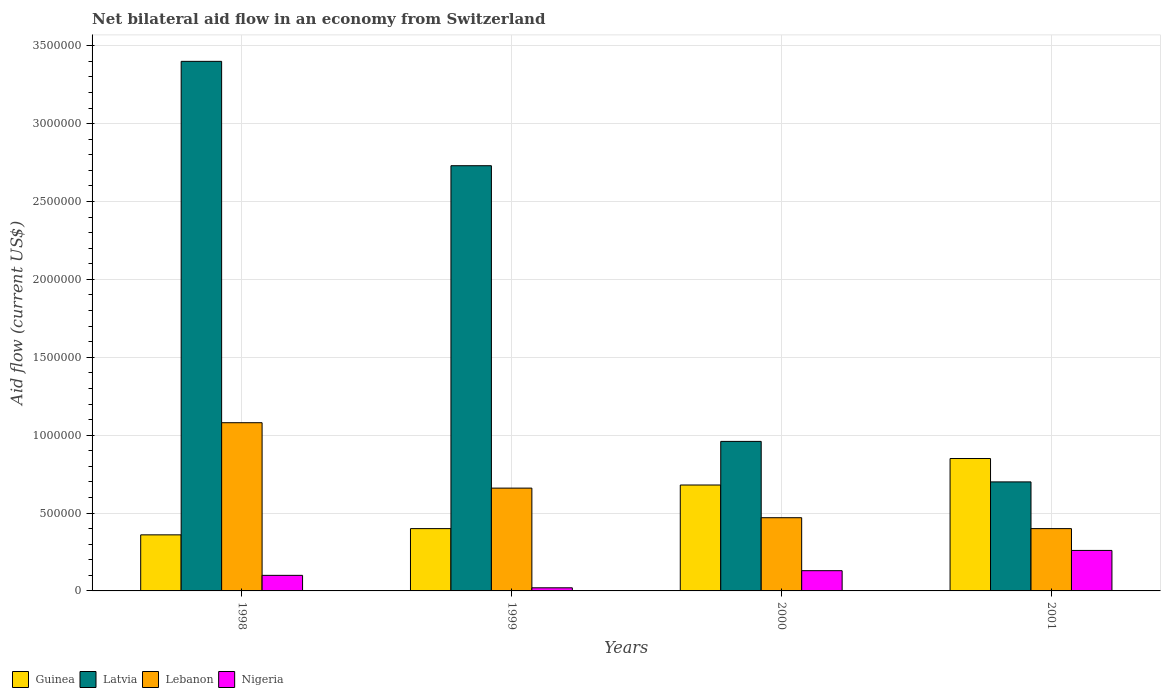How many different coloured bars are there?
Your answer should be compact. 4. How many groups of bars are there?
Make the answer very short. 4. What is the net bilateral aid flow in Latvia in 1998?
Offer a very short reply. 3.40e+06. Across all years, what is the maximum net bilateral aid flow in Lebanon?
Your answer should be compact. 1.08e+06. Across all years, what is the minimum net bilateral aid flow in Lebanon?
Offer a terse response. 4.00e+05. In which year was the net bilateral aid flow in Nigeria maximum?
Your response must be concise. 2001. In which year was the net bilateral aid flow in Nigeria minimum?
Keep it short and to the point. 1999. What is the total net bilateral aid flow in Nigeria in the graph?
Make the answer very short. 5.10e+05. What is the difference between the net bilateral aid flow in Lebanon in 1999 and that in 2001?
Your answer should be compact. 2.60e+05. What is the difference between the net bilateral aid flow in Lebanon in 2001 and the net bilateral aid flow in Nigeria in 1999?
Provide a short and direct response. 3.80e+05. What is the average net bilateral aid flow in Latvia per year?
Your answer should be very brief. 1.95e+06. In the year 1999, what is the difference between the net bilateral aid flow in Latvia and net bilateral aid flow in Guinea?
Your answer should be compact. 2.33e+06. In how many years, is the net bilateral aid flow in Latvia greater than 600000 US$?
Your response must be concise. 4. What is the ratio of the net bilateral aid flow in Guinea in 1998 to that in 2000?
Your answer should be very brief. 0.53. What is the difference between the highest and the second highest net bilateral aid flow in Nigeria?
Your response must be concise. 1.30e+05. What is the difference between the highest and the lowest net bilateral aid flow in Latvia?
Provide a short and direct response. 2.70e+06. Is it the case that in every year, the sum of the net bilateral aid flow in Nigeria and net bilateral aid flow in Guinea is greater than the sum of net bilateral aid flow in Lebanon and net bilateral aid flow in Latvia?
Keep it short and to the point. No. What does the 2nd bar from the left in 1998 represents?
Make the answer very short. Latvia. What does the 2nd bar from the right in 2000 represents?
Give a very brief answer. Lebanon. Is it the case that in every year, the sum of the net bilateral aid flow in Nigeria and net bilateral aid flow in Lebanon is greater than the net bilateral aid flow in Guinea?
Keep it short and to the point. No. Are all the bars in the graph horizontal?
Ensure brevity in your answer.  No. How many years are there in the graph?
Offer a terse response. 4. What is the difference between two consecutive major ticks on the Y-axis?
Provide a short and direct response. 5.00e+05. Are the values on the major ticks of Y-axis written in scientific E-notation?
Your answer should be very brief. No. Does the graph contain grids?
Your answer should be compact. Yes. How many legend labels are there?
Give a very brief answer. 4. How are the legend labels stacked?
Provide a short and direct response. Horizontal. What is the title of the graph?
Your answer should be very brief. Net bilateral aid flow in an economy from Switzerland. Does "Lithuania" appear as one of the legend labels in the graph?
Your answer should be compact. No. What is the label or title of the X-axis?
Provide a succinct answer. Years. What is the label or title of the Y-axis?
Give a very brief answer. Aid flow (current US$). What is the Aid flow (current US$) of Latvia in 1998?
Provide a succinct answer. 3.40e+06. What is the Aid flow (current US$) of Lebanon in 1998?
Make the answer very short. 1.08e+06. What is the Aid flow (current US$) of Guinea in 1999?
Your response must be concise. 4.00e+05. What is the Aid flow (current US$) of Latvia in 1999?
Make the answer very short. 2.73e+06. What is the Aid flow (current US$) in Nigeria in 1999?
Keep it short and to the point. 2.00e+04. What is the Aid flow (current US$) in Guinea in 2000?
Make the answer very short. 6.80e+05. What is the Aid flow (current US$) in Latvia in 2000?
Offer a terse response. 9.60e+05. What is the Aid flow (current US$) of Guinea in 2001?
Give a very brief answer. 8.50e+05. What is the Aid flow (current US$) in Latvia in 2001?
Give a very brief answer. 7.00e+05. What is the Aid flow (current US$) in Nigeria in 2001?
Offer a very short reply. 2.60e+05. Across all years, what is the maximum Aid flow (current US$) in Guinea?
Your answer should be compact. 8.50e+05. Across all years, what is the maximum Aid flow (current US$) of Latvia?
Your response must be concise. 3.40e+06. Across all years, what is the maximum Aid flow (current US$) of Lebanon?
Offer a very short reply. 1.08e+06. Across all years, what is the minimum Aid flow (current US$) of Latvia?
Give a very brief answer. 7.00e+05. What is the total Aid flow (current US$) in Guinea in the graph?
Your response must be concise. 2.29e+06. What is the total Aid flow (current US$) of Latvia in the graph?
Provide a short and direct response. 7.79e+06. What is the total Aid flow (current US$) of Lebanon in the graph?
Your answer should be very brief. 2.61e+06. What is the total Aid flow (current US$) of Nigeria in the graph?
Offer a terse response. 5.10e+05. What is the difference between the Aid flow (current US$) of Guinea in 1998 and that in 1999?
Provide a succinct answer. -4.00e+04. What is the difference between the Aid flow (current US$) in Latvia in 1998 and that in 1999?
Provide a succinct answer. 6.70e+05. What is the difference between the Aid flow (current US$) of Guinea in 1998 and that in 2000?
Provide a short and direct response. -3.20e+05. What is the difference between the Aid flow (current US$) of Latvia in 1998 and that in 2000?
Ensure brevity in your answer.  2.44e+06. What is the difference between the Aid flow (current US$) in Guinea in 1998 and that in 2001?
Give a very brief answer. -4.90e+05. What is the difference between the Aid flow (current US$) in Latvia in 1998 and that in 2001?
Your answer should be compact. 2.70e+06. What is the difference between the Aid flow (current US$) in Lebanon in 1998 and that in 2001?
Offer a terse response. 6.80e+05. What is the difference between the Aid flow (current US$) of Guinea in 1999 and that in 2000?
Offer a very short reply. -2.80e+05. What is the difference between the Aid flow (current US$) of Latvia in 1999 and that in 2000?
Keep it short and to the point. 1.77e+06. What is the difference between the Aid flow (current US$) of Lebanon in 1999 and that in 2000?
Keep it short and to the point. 1.90e+05. What is the difference between the Aid flow (current US$) of Nigeria in 1999 and that in 2000?
Keep it short and to the point. -1.10e+05. What is the difference between the Aid flow (current US$) of Guinea in 1999 and that in 2001?
Make the answer very short. -4.50e+05. What is the difference between the Aid flow (current US$) of Latvia in 1999 and that in 2001?
Keep it short and to the point. 2.03e+06. What is the difference between the Aid flow (current US$) in Lebanon in 1999 and that in 2001?
Provide a short and direct response. 2.60e+05. What is the difference between the Aid flow (current US$) of Nigeria in 1999 and that in 2001?
Offer a very short reply. -2.40e+05. What is the difference between the Aid flow (current US$) of Guinea in 2000 and that in 2001?
Your response must be concise. -1.70e+05. What is the difference between the Aid flow (current US$) in Latvia in 2000 and that in 2001?
Your answer should be very brief. 2.60e+05. What is the difference between the Aid flow (current US$) in Lebanon in 2000 and that in 2001?
Offer a very short reply. 7.00e+04. What is the difference between the Aid flow (current US$) in Guinea in 1998 and the Aid flow (current US$) in Latvia in 1999?
Your response must be concise. -2.37e+06. What is the difference between the Aid flow (current US$) of Guinea in 1998 and the Aid flow (current US$) of Lebanon in 1999?
Provide a succinct answer. -3.00e+05. What is the difference between the Aid flow (current US$) in Latvia in 1998 and the Aid flow (current US$) in Lebanon in 1999?
Offer a terse response. 2.74e+06. What is the difference between the Aid flow (current US$) in Latvia in 1998 and the Aid flow (current US$) in Nigeria in 1999?
Your answer should be very brief. 3.38e+06. What is the difference between the Aid flow (current US$) of Lebanon in 1998 and the Aid flow (current US$) of Nigeria in 1999?
Make the answer very short. 1.06e+06. What is the difference between the Aid flow (current US$) in Guinea in 1998 and the Aid flow (current US$) in Latvia in 2000?
Offer a terse response. -6.00e+05. What is the difference between the Aid flow (current US$) in Latvia in 1998 and the Aid flow (current US$) in Lebanon in 2000?
Provide a succinct answer. 2.93e+06. What is the difference between the Aid flow (current US$) in Latvia in 1998 and the Aid flow (current US$) in Nigeria in 2000?
Your answer should be compact. 3.27e+06. What is the difference between the Aid flow (current US$) in Lebanon in 1998 and the Aid flow (current US$) in Nigeria in 2000?
Provide a short and direct response. 9.50e+05. What is the difference between the Aid flow (current US$) of Guinea in 1998 and the Aid flow (current US$) of Lebanon in 2001?
Your response must be concise. -4.00e+04. What is the difference between the Aid flow (current US$) of Guinea in 1998 and the Aid flow (current US$) of Nigeria in 2001?
Ensure brevity in your answer.  1.00e+05. What is the difference between the Aid flow (current US$) of Latvia in 1998 and the Aid flow (current US$) of Lebanon in 2001?
Your answer should be very brief. 3.00e+06. What is the difference between the Aid flow (current US$) of Latvia in 1998 and the Aid flow (current US$) of Nigeria in 2001?
Give a very brief answer. 3.14e+06. What is the difference between the Aid flow (current US$) in Lebanon in 1998 and the Aid flow (current US$) in Nigeria in 2001?
Ensure brevity in your answer.  8.20e+05. What is the difference between the Aid flow (current US$) of Guinea in 1999 and the Aid flow (current US$) of Latvia in 2000?
Make the answer very short. -5.60e+05. What is the difference between the Aid flow (current US$) of Guinea in 1999 and the Aid flow (current US$) of Nigeria in 2000?
Your answer should be very brief. 2.70e+05. What is the difference between the Aid flow (current US$) in Latvia in 1999 and the Aid flow (current US$) in Lebanon in 2000?
Give a very brief answer. 2.26e+06. What is the difference between the Aid flow (current US$) of Latvia in 1999 and the Aid flow (current US$) of Nigeria in 2000?
Offer a terse response. 2.60e+06. What is the difference between the Aid flow (current US$) in Lebanon in 1999 and the Aid flow (current US$) in Nigeria in 2000?
Ensure brevity in your answer.  5.30e+05. What is the difference between the Aid flow (current US$) in Latvia in 1999 and the Aid flow (current US$) in Lebanon in 2001?
Ensure brevity in your answer.  2.33e+06. What is the difference between the Aid flow (current US$) of Latvia in 1999 and the Aid flow (current US$) of Nigeria in 2001?
Your response must be concise. 2.47e+06. What is the difference between the Aid flow (current US$) of Lebanon in 1999 and the Aid flow (current US$) of Nigeria in 2001?
Your answer should be very brief. 4.00e+05. What is the difference between the Aid flow (current US$) in Guinea in 2000 and the Aid flow (current US$) in Lebanon in 2001?
Make the answer very short. 2.80e+05. What is the difference between the Aid flow (current US$) in Latvia in 2000 and the Aid flow (current US$) in Lebanon in 2001?
Keep it short and to the point. 5.60e+05. What is the difference between the Aid flow (current US$) of Latvia in 2000 and the Aid flow (current US$) of Nigeria in 2001?
Provide a short and direct response. 7.00e+05. What is the difference between the Aid flow (current US$) in Lebanon in 2000 and the Aid flow (current US$) in Nigeria in 2001?
Your response must be concise. 2.10e+05. What is the average Aid flow (current US$) of Guinea per year?
Make the answer very short. 5.72e+05. What is the average Aid flow (current US$) in Latvia per year?
Provide a succinct answer. 1.95e+06. What is the average Aid flow (current US$) of Lebanon per year?
Your answer should be very brief. 6.52e+05. What is the average Aid flow (current US$) in Nigeria per year?
Provide a short and direct response. 1.28e+05. In the year 1998, what is the difference between the Aid flow (current US$) of Guinea and Aid flow (current US$) of Latvia?
Your response must be concise. -3.04e+06. In the year 1998, what is the difference between the Aid flow (current US$) in Guinea and Aid flow (current US$) in Lebanon?
Offer a terse response. -7.20e+05. In the year 1998, what is the difference between the Aid flow (current US$) of Latvia and Aid flow (current US$) of Lebanon?
Your answer should be compact. 2.32e+06. In the year 1998, what is the difference between the Aid flow (current US$) of Latvia and Aid flow (current US$) of Nigeria?
Give a very brief answer. 3.30e+06. In the year 1998, what is the difference between the Aid flow (current US$) in Lebanon and Aid flow (current US$) in Nigeria?
Make the answer very short. 9.80e+05. In the year 1999, what is the difference between the Aid flow (current US$) in Guinea and Aid flow (current US$) in Latvia?
Make the answer very short. -2.33e+06. In the year 1999, what is the difference between the Aid flow (current US$) of Guinea and Aid flow (current US$) of Nigeria?
Provide a short and direct response. 3.80e+05. In the year 1999, what is the difference between the Aid flow (current US$) of Latvia and Aid flow (current US$) of Lebanon?
Your answer should be compact. 2.07e+06. In the year 1999, what is the difference between the Aid flow (current US$) in Latvia and Aid flow (current US$) in Nigeria?
Provide a succinct answer. 2.71e+06. In the year 1999, what is the difference between the Aid flow (current US$) of Lebanon and Aid flow (current US$) of Nigeria?
Your answer should be very brief. 6.40e+05. In the year 2000, what is the difference between the Aid flow (current US$) in Guinea and Aid flow (current US$) in Latvia?
Keep it short and to the point. -2.80e+05. In the year 2000, what is the difference between the Aid flow (current US$) of Latvia and Aid flow (current US$) of Lebanon?
Provide a short and direct response. 4.90e+05. In the year 2000, what is the difference between the Aid flow (current US$) of Latvia and Aid flow (current US$) of Nigeria?
Keep it short and to the point. 8.30e+05. In the year 2000, what is the difference between the Aid flow (current US$) in Lebanon and Aid flow (current US$) in Nigeria?
Offer a terse response. 3.40e+05. In the year 2001, what is the difference between the Aid flow (current US$) in Guinea and Aid flow (current US$) in Latvia?
Your response must be concise. 1.50e+05. In the year 2001, what is the difference between the Aid flow (current US$) of Guinea and Aid flow (current US$) of Lebanon?
Provide a succinct answer. 4.50e+05. In the year 2001, what is the difference between the Aid flow (current US$) of Guinea and Aid flow (current US$) of Nigeria?
Make the answer very short. 5.90e+05. In the year 2001, what is the difference between the Aid flow (current US$) of Latvia and Aid flow (current US$) of Lebanon?
Make the answer very short. 3.00e+05. In the year 2001, what is the difference between the Aid flow (current US$) in Latvia and Aid flow (current US$) in Nigeria?
Give a very brief answer. 4.40e+05. What is the ratio of the Aid flow (current US$) of Guinea in 1998 to that in 1999?
Give a very brief answer. 0.9. What is the ratio of the Aid flow (current US$) in Latvia in 1998 to that in 1999?
Provide a succinct answer. 1.25. What is the ratio of the Aid flow (current US$) in Lebanon in 1998 to that in 1999?
Make the answer very short. 1.64. What is the ratio of the Aid flow (current US$) of Nigeria in 1998 to that in 1999?
Your answer should be very brief. 5. What is the ratio of the Aid flow (current US$) in Guinea in 1998 to that in 2000?
Provide a succinct answer. 0.53. What is the ratio of the Aid flow (current US$) in Latvia in 1998 to that in 2000?
Keep it short and to the point. 3.54. What is the ratio of the Aid flow (current US$) in Lebanon in 1998 to that in 2000?
Offer a very short reply. 2.3. What is the ratio of the Aid flow (current US$) in Nigeria in 1998 to that in 2000?
Give a very brief answer. 0.77. What is the ratio of the Aid flow (current US$) of Guinea in 1998 to that in 2001?
Ensure brevity in your answer.  0.42. What is the ratio of the Aid flow (current US$) of Latvia in 1998 to that in 2001?
Give a very brief answer. 4.86. What is the ratio of the Aid flow (current US$) of Nigeria in 1998 to that in 2001?
Your answer should be very brief. 0.38. What is the ratio of the Aid flow (current US$) of Guinea in 1999 to that in 2000?
Give a very brief answer. 0.59. What is the ratio of the Aid flow (current US$) in Latvia in 1999 to that in 2000?
Your answer should be compact. 2.84. What is the ratio of the Aid flow (current US$) in Lebanon in 1999 to that in 2000?
Offer a very short reply. 1.4. What is the ratio of the Aid flow (current US$) of Nigeria in 1999 to that in 2000?
Give a very brief answer. 0.15. What is the ratio of the Aid flow (current US$) in Guinea in 1999 to that in 2001?
Your answer should be compact. 0.47. What is the ratio of the Aid flow (current US$) in Latvia in 1999 to that in 2001?
Your response must be concise. 3.9. What is the ratio of the Aid flow (current US$) of Lebanon in 1999 to that in 2001?
Give a very brief answer. 1.65. What is the ratio of the Aid flow (current US$) in Nigeria in 1999 to that in 2001?
Your answer should be compact. 0.08. What is the ratio of the Aid flow (current US$) in Guinea in 2000 to that in 2001?
Provide a succinct answer. 0.8. What is the ratio of the Aid flow (current US$) in Latvia in 2000 to that in 2001?
Your response must be concise. 1.37. What is the ratio of the Aid flow (current US$) in Lebanon in 2000 to that in 2001?
Your answer should be compact. 1.18. What is the ratio of the Aid flow (current US$) of Nigeria in 2000 to that in 2001?
Make the answer very short. 0.5. What is the difference between the highest and the second highest Aid flow (current US$) in Latvia?
Make the answer very short. 6.70e+05. What is the difference between the highest and the second highest Aid flow (current US$) in Lebanon?
Provide a succinct answer. 4.20e+05. What is the difference between the highest and the second highest Aid flow (current US$) in Nigeria?
Provide a short and direct response. 1.30e+05. What is the difference between the highest and the lowest Aid flow (current US$) in Latvia?
Make the answer very short. 2.70e+06. What is the difference between the highest and the lowest Aid flow (current US$) of Lebanon?
Offer a terse response. 6.80e+05. What is the difference between the highest and the lowest Aid flow (current US$) in Nigeria?
Offer a very short reply. 2.40e+05. 